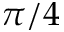<formula> <loc_0><loc_0><loc_500><loc_500>\pi / 4</formula> 